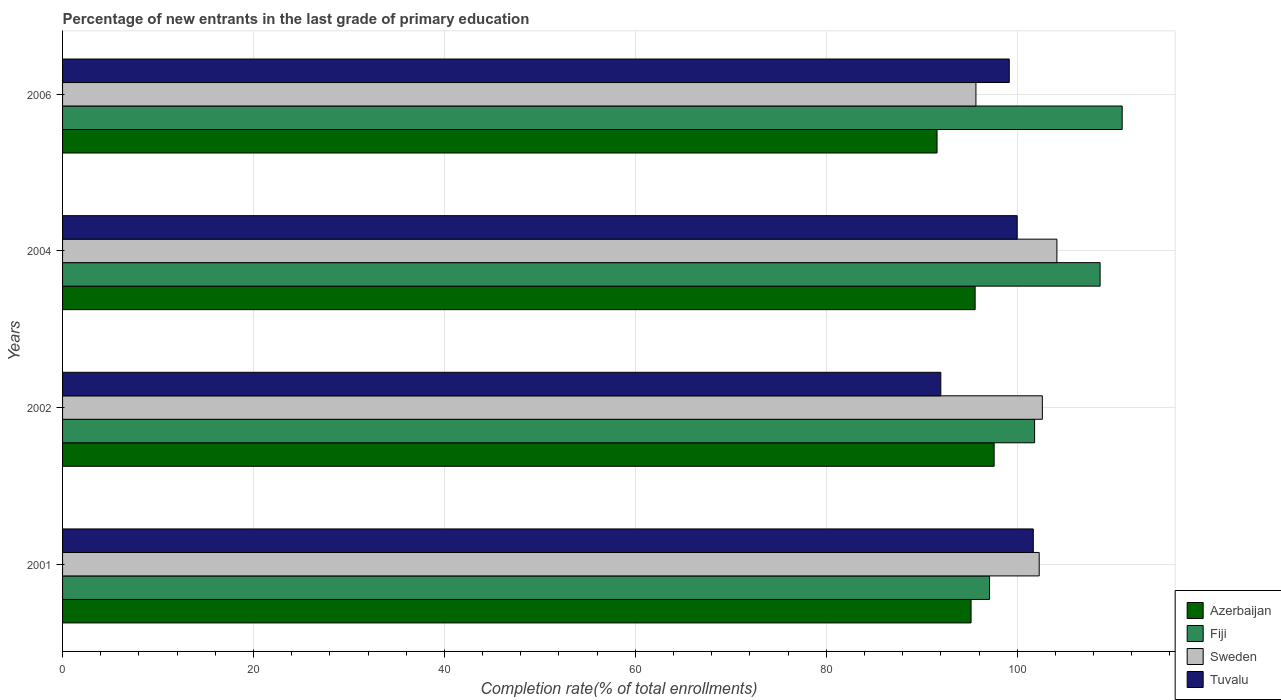Are the number of bars on each tick of the Y-axis equal?
Your answer should be compact. Yes. How many bars are there on the 4th tick from the bottom?
Offer a very short reply. 4. What is the label of the 2nd group of bars from the top?
Make the answer very short. 2004. In how many cases, is the number of bars for a given year not equal to the number of legend labels?
Your response must be concise. 0. What is the percentage of new entrants in Fiji in 2006?
Provide a short and direct response. 111. Across all years, what is the maximum percentage of new entrants in Fiji?
Keep it short and to the point. 111. Across all years, what is the minimum percentage of new entrants in Sweden?
Make the answer very short. 95.68. What is the total percentage of new entrants in Sweden in the graph?
Offer a terse response. 404.78. What is the difference between the percentage of new entrants in Azerbaijan in 2001 and that in 2002?
Offer a very short reply. -2.42. What is the difference between the percentage of new entrants in Sweden in 2004 and the percentage of new entrants in Azerbaijan in 2001?
Offer a very short reply. 8.99. What is the average percentage of new entrants in Sweden per year?
Provide a short and direct response. 101.2. In the year 2001, what is the difference between the percentage of new entrants in Azerbaijan and percentage of new entrants in Tuvalu?
Your response must be concise. -6.52. What is the ratio of the percentage of new entrants in Sweden in 2001 to that in 2006?
Offer a very short reply. 1.07. Is the percentage of new entrants in Fiji in 2001 less than that in 2002?
Keep it short and to the point. Yes. Is the difference between the percentage of new entrants in Azerbaijan in 2002 and 2006 greater than the difference between the percentage of new entrants in Tuvalu in 2002 and 2006?
Make the answer very short. Yes. What is the difference between the highest and the second highest percentage of new entrants in Tuvalu?
Offer a terse response. 1.69. What is the difference between the highest and the lowest percentage of new entrants in Tuvalu?
Keep it short and to the point. 9.69. Is the sum of the percentage of new entrants in Tuvalu in 2001 and 2002 greater than the maximum percentage of new entrants in Azerbaijan across all years?
Give a very brief answer. Yes. What does the 1st bar from the top in 2004 represents?
Your answer should be compact. Tuvalu. What does the 2nd bar from the bottom in 2004 represents?
Your answer should be very brief. Fiji. Is it the case that in every year, the sum of the percentage of new entrants in Fiji and percentage of new entrants in Sweden is greater than the percentage of new entrants in Azerbaijan?
Offer a terse response. Yes. What is the difference between two consecutive major ticks on the X-axis?
Provide a succinct answer. 20. Does the graph contain any zero values?
Offer a very short reply. No. Does the graph contain grids?
Ensure brevity in your answer.  Yes. How many legend labels are there?
Keep it short and to the point. 4. How are the legend labels stacked?
Provide a short and direct response. Vertical. What is the title of the graph?
Your answer should be very brief. Percentage of new entrants in the last grade of primary education. Does "Arab World" appear as one of the legend labels in the graph?
Offer a very short reply. No. What is the label or title of the X-axis?
Provide a succinct answer. Completion rate(% of total enrollments). What is the label or title of the Y-axis?
Ensure brevity in your answer.  Years. What is the Completion rate(% of total enrollments) in Azerbaijan in 2001?
Provide a succinct answer. 95.17. What is the Completion rate(% of total enrollments) in Fiji in 2001?
Offer a terse response. 97.11. What is the Completion rate(% of total enrollments) of Sweden in 2001?
Ensure brevity in your answer.  102.31. What is the Completion rate(% of total enrollments) of Tuvalu in 2001?
Make the answer very short. 101.69. What is the Completion rate(% of total enrollments) in Azerbaijan in 2002?
Your answer should be compact. 97.59. What is the Completion rate(% of total enrollments) in Fiji in 2002?
Offer a terse response. 101.83. What is the Completion rate(% of total enrollments) in Sweden in 2002?
Keep it short and to the point. 102.64. What is the Completion rate(% of total enrollments) in Tuvalu in 2002?
Your response must be concise. 92. What is the Completion rate(% of total enrollments) of Azerbaijan in 2004?
Ensure brevity in your answer.  95.6. What is the Completion rate(% of total enrollments) of Fiji in 2004?
Your answer should be very brief. 108.69. What is the Completion rate(% of total enrollments) of Sweden in 2004?
Provide a short and direct response. 104.16. What is the Completion rate(% of total enrollments) of Azerbaijan in 2006?
Your answer should be compact. 91.61. What is the Completion rate(% of total enrollments) in Fiji in 2006?
Your answer should be compact. 111. What is the Completion rate(% of total enrollments) in Sweden in 2006?
Ensure brevity in your answer.  95.68. What is the Completion rate(% of total enrollments) of Tuvalu in 2006?
Offer a terse response. 99.17. Across all years, what is the maximum Completion rate(% of total enrollments) in Azerbaijan?
Offer a very short reply. 97.59. Across all years, what is the maximum Completion rate(% of total enrollments) of Fiji?
Give a very brief answer. 111. Across all years, what is the maximum Completion rate(% of total enrollments) in Sweden?
Offer a very short reply. 104.16. Across all years, what is the maximum Completion rate(% of total enrollments) in Tuvalu?
Your answer should be compact. 101.69. Across all years, what is the minimum Completion rate(% of total enrollments) in Azerbaijan?
Provide a succinct answer. 91.61. Across all years, what is the minimum Completion rate(% of total enrollments) of Fiji?
Provide a succinct answer. 97.11. Across all years, what is the minimum Completion rate(% of total enrollments) of Sweden?
Provide a succinct answer. 95.68. Across all years, what is the minimum Completion rate(% of total enrollments) in Tuvalu?
Offer a very short reply. 92. What is the total Completion rate(% of total enrollments) in Azerbaijan in the graph?
Make the answer very short. 379.96. What is the total Completion rate(% of total enrollments) in Fiji in the graph?
Give a very brief answer. 418.62. What is the total Completion rate(% of total enrollments) of Sweden in the graph?
Offer a very short reply. 404.78. What is the total Completion rate(% of total enrollments) in Tuvalu in the graph?
Your answer should be very brief. 392.86. What is the difference between the Completion rate(% of total enrollments) of Azerbaijan in 2001 and that in 2002?
Keep it short and to the point. -2.42. What is the difference between the Completion rate(% of total enrollments) of Fiji in 2001 and that in 2002?
Keep it short and to the point. -4.72. What is the difference between the Completion rate(% of total enrollments) in Sweden in 2001 and that in 2002?
Keep it short and to the point. -0.33. What is the difference between the Completion rate(% of total enrollments) of Tuvalu in 2001 and that in 2002?
Provide a short and direct response. 9.69. What is the difference between the Completion rate(% of total enrollments) in Azerbaijan in 2001 and that in 2004?
Ensure brevity in your answer.  -0.43. What is the difference between the Completion rate(% of total enrollments) of Fiji in 2001 and that in 2004?
Your answer should be compact. -11.58. What is the difference between the Completion rate(% of total enrollments) of Sweden in 2001 and that in 2004?
Offer a terse response. -1.85. What is the difference between the Completion rate(% of total enrollments) of Tuvalu in 2001 and that in 2004?
Make the answer very short. 1.69. What is the difference between the Completion rate(% of total enrollments) of Azerbaijan in 2001 and that in 2006?
Your answer should be compact. 3.56. What is the difference between the Completion rate(% of total enrollments) of Fiji in 2001 and that in 2006?
Provide a short and direct response. -13.89. What is the difference between the Completion rate(% of total enrollments) in Sweden in 2001 and that in 2006?
Keep it short and to the point. 6.63. What is the difference between the Completion rate(% of total enrollments) of Tuvalu in 2001 and that in 2006?
Your response must be concise. 2.52. What is the difference between the Completion rate(% of total enrollments) of Azerbaijan in 2002 and that in 2004?
Provide a short and direct response. 1.99. What is the difference between the Completion rate(% of total enrollments) in Fiji in 2002 and that in 2004?
Keep it short and to the point. -6.86. What is the difference between the Completion rate(% of total enrollments) in Sweden in 2002 and that in 2004?
Give a very brief answer. -1.53. What is the difference between the Completion rate(% of total enrollments) in Tuvalu in 2002 and that in 2004?
Offer a very short reply. -8. What is the difference between the Completion rate(% of total enrollments) in Azerbaijan in 2002 and that in 2006?
Make the answer very short. 5.98. What is the difference between the Completion rate(% of total enrollments) of Fiji in 2002 and that in 2006?
Ensure brevity in your answer.  -9.17. What is the difference between the Completion rate(% of total enrollments) in Sweden in 2002 and that in 2006?
Ensure brevity in your answer.  6.96. What is the difference between the Completion rate(% of total enrollments) in Tuvalu in 2002 and that in 2006?
Ensure brevity in your answer.  -7.17. What is the difference between the Completion rate(% of total enrollments) in Azerbaijan in 2004 and that in 2006?
Your response must be concise. 3.99. What is the difference between the Completion rate(% of total enrollments) of Fiji in 2004 and that in 2006?
Ensure brevity in your answer.  -2.31. What is the difference between the Completion rate(% of total enrollments) in Sweden in 2004 and that in 2006?
Ensure brevity in your answer.  8.48. What is the difference between the Completion rate(% of total enrollments) in Tuvalu in 2004 and that in 2006?
Make the answer very short. 0.83. What is the difference between the Completion rate(% of total enrollments) in Azerbaijan in 2001 and the Completion rate(% of total enrollments) in Fiji in 2002?
Your response must be concise. -6.66. What is the difference between the Completion rate(% of total enrollments) of Azerbaijan in 2001 and the Completion rate(% of total enrollments) of Sweden in 2002?
Your answer should be very brief. -7.47. What is the difference between the Completion rate(% of total enrollments) in Azerbaijan in 2001 and the Completion rate(% of total enrollments) in Tuvalu in 2002?
Your answer should be very brief. 3.17. What is the difference between the Completion rate(% of total enrollments) of Fiji in 2001 and the Completion rate(% of total enrollments) of Sweden in 2002?
Offer a very short reply. -5.53. What is the difference between the Completion rate(% of total enrollments) in Fiji in 2001 and the Completion rate(% of total enrollments) in Tuvalu in 2002?
Your answer should be very brief. 5.11. What is the difference between the Completion rate(% of total enrollments) of Sweden in 2001 and the Completion rate(% of total enrollments) of Tuvalu in 2002?
Provide a short and direct response. 10.31. What is the difference between the Completion rate(% of total enrollments) in Azerbaijan in 2001 and the Completion rate(% of total enrollments) in Fiji in 2004?
Provide a succinct answer. -13.52. What is the difference between the Completion rate(% of total enrollments) in Azerbaijan in 2001 and the Completion rate(% of total enrollments) in Sweden in 2004?
Provide a succinct answer. -8.99. What is the difference between the Completion rate(% of total enrollments) in Azerbaijan in 2001 and the Completion rate(% of total enrollments) in Tuvalu in 2004?
Your answer should be compact. -4.83. What is the difference between the Completion rate(% of total enrollments) in Fiji in 2001 and the Completion rate(% of total enrollments) in Sweden in 2004?
Give a very brief answer. -7.05. What is the difference between the Completion rate(% of total enrollments) of Fiji in 2001 and the Completion rate(% of total enrollments) of Tuvalu in 2004?
Your answer should be very brief. -2.89. What is the difference between the Completion rate(% of total enrollments) of Sweden in 2001 and the Completion rate(% of total enrollments) of Tuvalu in 2004?
Make the answer very short. 2.31. What is the difference between the Completion rate(% of total enrollments) in Azerbaijan in 2001 and the Completion rate(% of total enrollments) in Fiji in 2006?
Your answer should be very brief. -15.83. What is the difference between the Completion rate(% of total enrollments) in Azerbaijan in 2001 and the Completion rate(% of total enrollments) in Sweden in 2006?
Your answer should be very brief. -0.51. What is the difference between the Completion rate(% of total enrollments) in Azerbaijan in 2001 and the Completion rate(% of total enrollments) in Tuvalu in 2006?
Give a very brief answer. -4. What is the difference between the Completion rate(% of total enrollments) of Fiji in 2001 and the Completion rate(% of total enrollments) of Sweden in 2006?
Offer a terse response. 1.43. What is the difference between the Completion rate(% of total enrollments) of Fiji in 2001 and the Completion rate(% of total enrollments) of Tuvalu in 2006?
Offer a very short reply. -2.06. What is the difference between the Completion rate(% of total enrollments) in Sweden in 2001 and the Completion rate(% of total enrollments) in Tuvalu in 2006?
Provide a succinct answer. 3.14. What is the difference between the Completion rate(% of total enrollments) of Azerbaijan in 2002 and the Completion rate(% of total enrollments) of Fiji in 2004?
Keep it short and to the point. -11.1. What is the difference between the Completion rate(% of total enrollments) of Azerbaijan in 2002 and the Completion rate(% of total enrollments) of Sweden in 2004?
Your answer should be very brief. -6.57. What is the difference between the Completion rate(% of total enrollments) in Azerbaijan in 2002 and the Completion rate(% of total enrollments) in Tuvalu in 2004?
Your answer should be very brief. -2.41. What is the difference between the Completion rate(% of total enrollments) of Fiji in 2002 and the Completion rate(% of total enrollments) of Sweden in 2004?
Give a very brief answer. -2.34. What is the difference between the Completion rate(% of total enrollments) of Fiji in 2002 and the Completion rate(% of total enrollments) of Tuvalu in 2004?
Your answer should be very brief. 1.83. What is the difference between the Completion rate(% of total enrollments) in Sweden in 2002 and the Completion rate(% of total enrollments) in Tuvalu in 2004?
Make the answer very short. 2.64. What is the difference between the Completion rate(% of total enrollments) in Azerbaijan in 2002 and the Completion rate(% of total enrollments) in Fiji in 2006?
Your answer should be compact. -13.41. What is the difference between the Completion rate(% of total enrollments) of Azerbaijan in 2002 and the Completion rate(% of total enrollments) of Sweden in 2006?
Keep it short and to the point. 1.91. What is the difference between the Completion rate(% of total enrollments) of Azerbaijan in 2002 and the Completion rate(% of total enrollments) of Tuvalu in 2006?
Make the answer very short. -1.58. What is the difference between the Completion rate(% of total enrollments) of Fiji in 2002 and the Completion rate(% of total enrollments) of Sweden in 2006?
Keep it short and to the point. 6.15. What is the difference between the Completion rate(% of total enrollments) in Fiji in 2002 and the Completion rate(% of total enrollments) in Tuvalu in 2006?
Ensure brevity in your answer.  2.66. What is the difference between the Completion rate(% of total enrollments) of Sweden in 2002 and the Completion rate(% of total enrollments) of Tuvalu in 2006?
Make the answer very short. 3.47. What is the difference between the Completion rate(% of total enrollments) in Azerbaijan in 2004 and the Completion rate(% of total enrollments) in Fiji in 2006?
Keep it short and to the point. -15.4. What is the difference between the Completion rate(% of total enrollments) in Azerbaijan in 2004 and the Completion rate(% of total enrollments) in Sweden in 2006?
Give a very brief answer. -0.08. What is the difference between the Completion rate(% of total enrollments) in Azerbaijan in 2004 and the Completion rate(% of total enrollments) in Tuvalu in 2006?
Give a very brief answer. -3.57. What is the difference between the Completion rate(% of total enrollments) of Fiji in 2004 and the Completion rate(% of total enrollments) of Sweden in 2006?
Give a very brief answer. 13.01. What is the difference between the Completion rate(% of total enrollments) of Fiji in 2004 and the Completion rate(% of total enrollments) of Tuvalu in 2006?
Ensure brevity in your answer.  9.52. What is the difference between the Completion rate(% of total enrollments) of Sweden in 2004 and the Completion rate(% of total enrollments) of Tuvalu in 2006?
Provide a short and direct response. 4.99. What is the average Completion rate(% of total enrollments) in Azerbaijan per year?
Offer a terse response. 94.99. What is the average Completion rate(% of total enrollments) of Fiji per year?
Offer a very short reply. 104.65. What is the average Completion rate(% of total enrollments) in Sweden per year?
Your response must be concise. 101.2. What is the average Completion rate(% of total enrollments) in Tuvalu per year?
Provide a short and direct response. 98.21. In the year 2001, what is the difference between the Completion rate(% of total enrollments) in Azerbaijan and Completion rate(% of total enrollments) in Fiji?
Your answer should be very brief. -1.94. In the year 2001, what is the difference between the Completion rate(% of total enrollments) in Azerbaijan and Completion rate(% of total enrollments) in Sweden?
Offer a terse response. -7.14. In the year 2001, what is the difference between the Completion rate(% of total enrollments) in Azerbaijan and Completion rate(% of total enrollments) in Tuvalu?
Keep it short and to the point. -6.52. In the year 2001, what is the difference between the Completion rate(% of total enrollments) in Fiji and Completion rate(% of total enrollments) in Sweden?
Keep it short and to the point. -5.2. In the year 2001, what is the difference between the Completion rate(% of total enrollments) of Fiji and Completion rate(% of total enrollments) of Tuvalu?
Give a very brief answer. -4.58. In the year 2001, what is the difference between the Completion rate(% of total enrollments) in Sweden and Completion rate(% of total enrollments) in Tuvalu?
Your answer should be very brief. 0.62. In the year 2002, what is the difference between the Completion rate(% of total enrollments) in Azerbaijan and Completion rate(% of total enrollments) in Fiji?
Give a very brief answer. -4.24. In the year 2002, what is the difference between the Completion rate(% of total enrollments) of Azerbaijan and Completion rate(% of total enrollments) of Sweden?
Keep it short and to the point. -5.05. In the year 2002, what is the difference between the Completion rate(% of total enrollments) of Azerbaijan and Completion rate(% of total enrollments) of Tuvalu?
Your answer should be very brief. 5.59. In the year 2002, what is the difference between the Completion rate(% of total enrollments) in Fiji and Completion rate(% of total enrollments) in Sweden?
Your answer should be compact. -0.81. In the year 2002, what is the difference between the Completion rate(% of total enrollments) in Fiji and Completion rate(% of total enrollments) in Tuvalu?
Your answer should be very brief. 9.83. In the year 2002, what is the difference between the Completion rate(% of total enrollments) in Sweden and Completion rate(% of total enrollments) in Tuvalu?
Offer a terse response. 10.64. In the year 2004, what is the difference between the Completion rate(% of total enrollments) of Azerbaijan and Completion rate(% of total enrollments) of Fiji?
Your response must be concise. -13.09. In the year 2004, what is the difference between the Completion rate(% of total enrollments) of Azerbaijan and Completion rate(% of total enrollments) of Sweden?
Your answer should be compact. -8.57. In the year 2004, what is the difference between the Completion rate(% of total enrollments) in Azerbaijan and Completion rate(% of total enrollments) in Tuvalu?
Keep it short and to the point. -4.4. In the year 2004, what is the difference between the Completion rate(% of total enrollments) in Fiji and Completion rate(% of total enrollments) in Sweden?
Your answer should be compact. 4.53. In the year 2004, what is the difference between the Completion rate(% of total enrollments) of Fiji and Completion rate(% of total enrollments) of Tuvalu?
Offer a very short reply. 8.69. In the year 2004, what is the difference between the Completion rate(% of total enrollments) of Sweden and Completion rate(% of total enrollments) of Tuvalu?
Give a very brief answer. 4.16. In the year 2006, what is the difference between the Completion rate(% of total enrollments) of Azerbaijan and Completion rate(% of total enrollments) of Fiji?
Your answer should be compact. -19.39. In the year 2006, what is the difference between the Completion rate(% of total enrollments) of Azerbaijan and Completion rate(% of total enrollments) of Sweden?
Your answer should be compact. -4.07. In the year 2006, what is the difference between the Completion rate(% of total enrollments) of Azerbaijan and Completion rate(% of total enrollments) of Tuvalu?
Ensure brevity in your answer.  -7.56. In the year 2006, what is the difference between the Completion rate(% of total enrollments) in Fiji and Completion rate(% of total enrollments) in Sweden?
Your answer should be very brief. 15.32. In the year 2006, what is the difference between the Completion rate(% of total enrollments) of Fiji and Completion rate(% of total enrollments) of Tuvalu?
Ensure brevity in your answer.  11.83. In the year 2006, what is the difference between the Completion rate(% of total enrollments) of Sweden and Completion rate(% of total enrollments) of Tuvalu?
Your answer should be very brief. -3.49. What is the ratio of the Completion rate(% of total enrollments) in Azerbaijan in 2001 to that in 2002?
Offer a very short reply. 0.98. What is the ratio of the Completion rate(% of total enrollments) in Fiji in 2001 to that in 2002?
Your answer should be compact. 0.95. What is the ratio of the Completion rate(% of total enrollments) in Tuvalu in 2001 to that in 2002?
Your response must be concise. 1.11. What is the ratio of the Completion rate(% of total enrollments) in Azerbaijan in 2001 to that in 2004?
Make the answer very short. 1. What is the ratio of the Completion rate(% of total enrollments) of Fiji in 2001 to that in 2004?
Your answer should be very brief. 0.89. What is the ratio of the Completion rate(% of total enrollments) in Sweden in 2001 to that in 2004?
Your response must be concise. 0.98. What is the ratio of the Completion rate(% of total enrollments) of Tuvalu in 2001 to that in 2004?
Your answer should be very brief. 1.02. What is the ratio of the Completion rate(% of total enrollments) of Azerbaijan in 2001 to that in 2006?
Provide a short and direct response. 1.04. What is the ratio of the Completion rate(% of total enrollments) of Fiji in 2001 to that in 2006?
Keep it short and to the point. 0.87. What is the ratio of the Completion rate(% of total enrollments) in Sweden in 2001 to that in 2006?
Your answer should be very brief. 1.07. What is the ratio of the Completion rate(% of total enrollments) of Tuvalu in 2001 to that in 2006?
Ensure brevity in your answer.  1.03. What is the ratio of the Completion rate(% of total enrollments) in Azerbaijan in 2002 to that in 2004?
Offer a very short reply. 1.02. What is the ratio of the Completion rate(% of total enrollments) in Fiji in 2002 to that in 2004?
Keep it short and to the point. 0.94. What is the ratio of the Completion rate(% of total enrollments) of Sweden in 2002 to that in 2004?
Provide a succinct answer. 0.99. What is the ratio of the Completion rate(% of total enrollments) in Azerbaijan in 2002 to that in 2006?
Offer a terse response. 1.07. What is the ratio of the Completion rate(% of total enrollments) of Fiji in 2002 to that in 2006?
Provide a short and direct response. 0.92. What is the ratio of the Completion rate(% of total enrollments) in Sweden in 2002 to that in 2006?
Ensure brevity in your answer.  1.07. What is the ratio of the Completion rate(% of total enrollments) of Tuvalu in 2002 to that in 2006?
Provide a short and direct response. 0.93. What is the ratio of the Completion rate(% of total enrollments) in Azerbaijan in 2004 to that in 2006?
Make the answer very short. 1.04. What is the ratio of the Completion rate(% of total enrollments) in Fiji in 2004 to that in 2006?
Offer a terse response. 0.98. What is the ratio of the Completion rate(% of total enrollments) in Sweden in 2004 to that in 2006?
Make the answer very short. 1.09. What is the ratio of the Completion rate(% of total enrollments) in Tuvalu in 2004 to that in 2006?
Give a very brief answer. 1.01. What is the difference between the highest and the second highest Completion rate(% of total enrollments) in Azerbaijan?
Give a very brief answer. 1.99. What is the difference between the highest and the second highest Completion rate(% of total enrollments) in Fiji?
Your response must be concise. 2.31. What is the difference between the highest and the second highest Completion rate(% of total enrollments) of Sweden?
Give a very brief answer. 1.53. What is the difference between the highest and the second highest Completion rate(% of total enrollments) in Tuvalu?
Offer a terse response. 1.69. What is the difference between the highest and the lowest Completion rate(% of total enrollments) of Azerbaijan?
Give a very brief answer. 5.98. What is the difference between the highest and the lowest Completion rate(% of total enrollments) in Fiji?
Give a very brief answer. 13.89. What is the difference between the highest and the lowest Completion rate(% of total enrollments) in Sweden?
Ensure brevity in your answer.  8.48. What is the difference between the highest and the lowest Completion rate(% of total enrollments) of Tuvalu?
Offer a terse response. 9.69. 